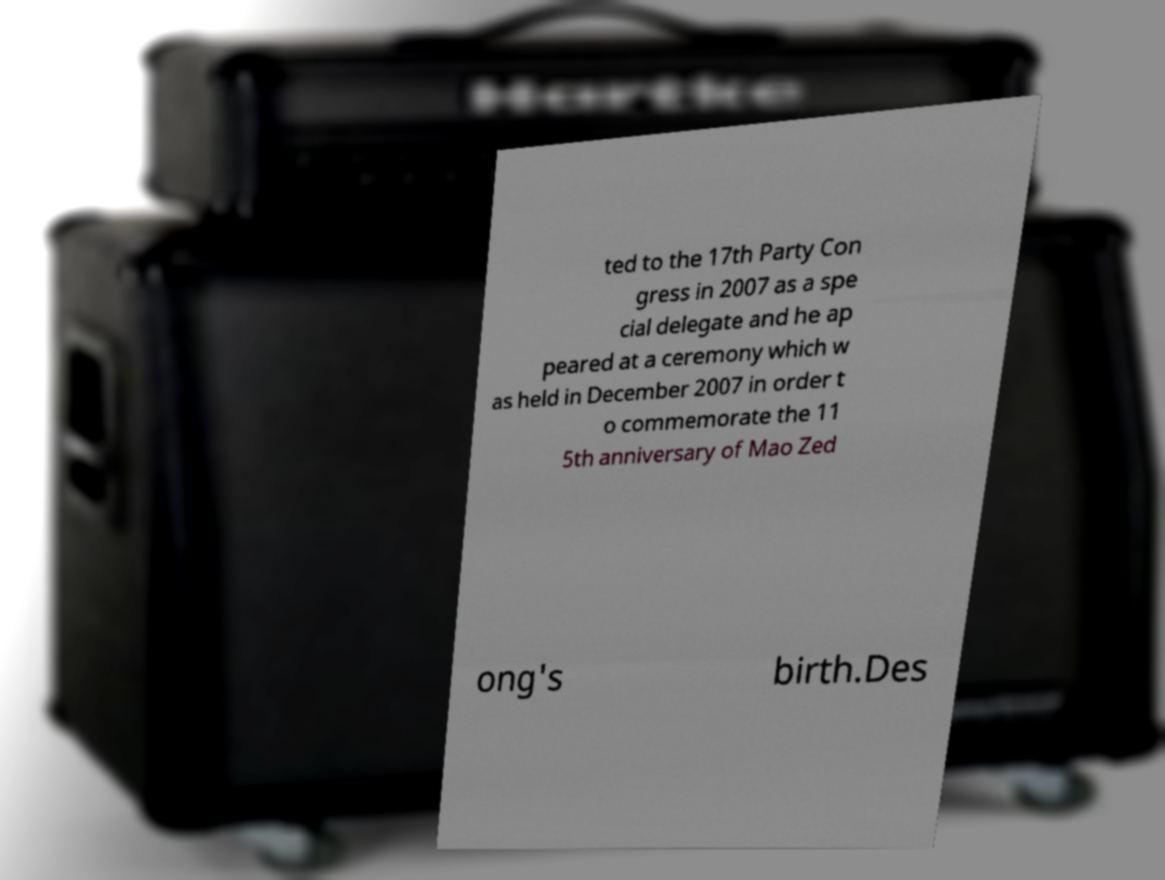Could you assist in decoding the text presented in this image and type it out clearly? ted to the 17th Party Con gress in 2007 as a spe cial delegate and he ap peared at a ceremony which w as held in December 2007 in order t o commemorate the 11 5th anniversary of Mao Zed ong's birth.Des 